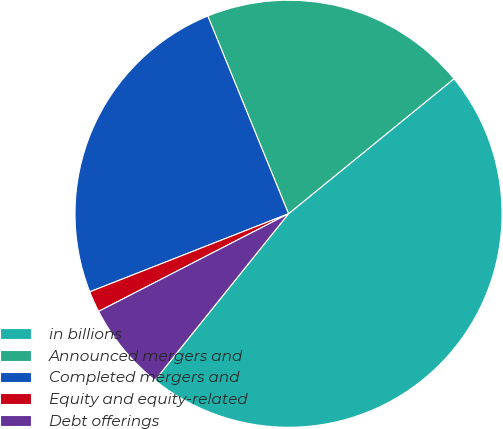Convert chart. <chart><loc_0><loc_0><loc_500><loc_500><pie_chart><fcel>in billions<fcel>Announced mergers and<fcel>Completed mergers and<fcel>Equity and equity-related<fcel>Debt offerings<nl><fcel>46.65%<fcel>20.28%<fcel>24.79%<fcel>1.6%<fcel>6.68%<nl></chart> 